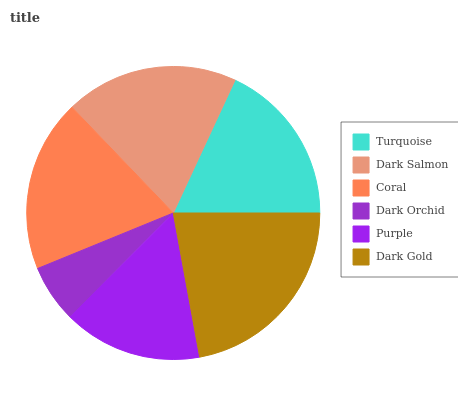Is Dark Orchid the minimum?
Answer yes or no. Yes. Is Dark Gold the maximum?
Answer yes or no. Yes. Is Dark Salmon the minimum?
Answer yes or no. No. Is Dark Salmon the maximum?
Answer yes or no. No. Is Dark Salmon greater than Turquoise?
Answer yes or no. Yes. Is Turquoise less than Dark Salmon?
Answer yes or no. Yes. Is Turquoise greater than Dark Salmon?
Answer yes or no. No. Is Dark Salmon less than Turquoise?
Answer yes or no. No. Is Coral the high median?
Answer yes or no. Yes. Is Turquoise the low median?
Answer yes or no. Yes. Is Dark Salmon the high median?
Answer yes or no. No. Is Dark Gold the low median?
Answer yes or no. No. 